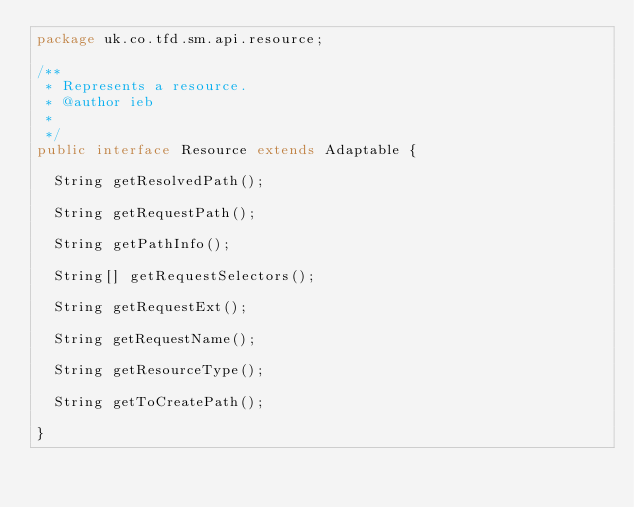Convert code to text. <code><loc_0><loc_0><loc_500><loc_500><_Java_>package uk.co.tfd.sm.api.resource;

/**
 * Represents a resource.
 * @author ieb
 *
 */
public interface Resource extends Adaptable {

	String getResolvedPath();

	String getRequestPath();

	String getPathInfo();

	String[] getRequestSelectors();

	String getRequestExt();

	String getRequestName();

	String getResourceType();

	String getToCreatePath();

}
</code> 